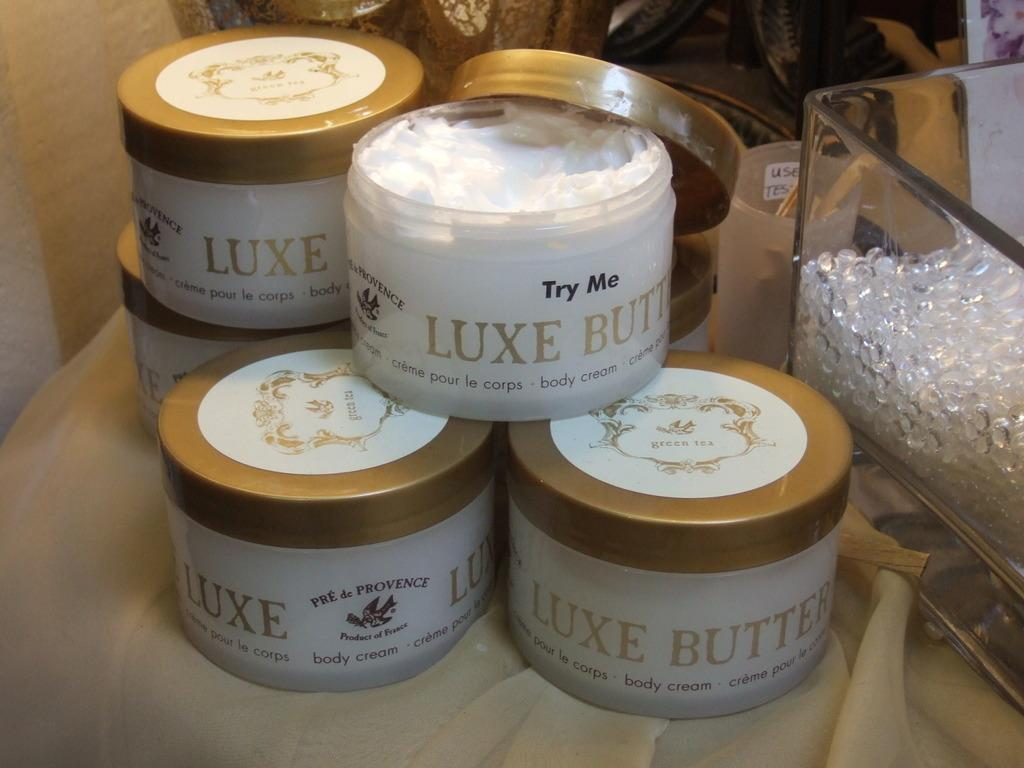<image>
Write a terse but informative summary of the picture. Six containers of Luxe Butter on a table. 